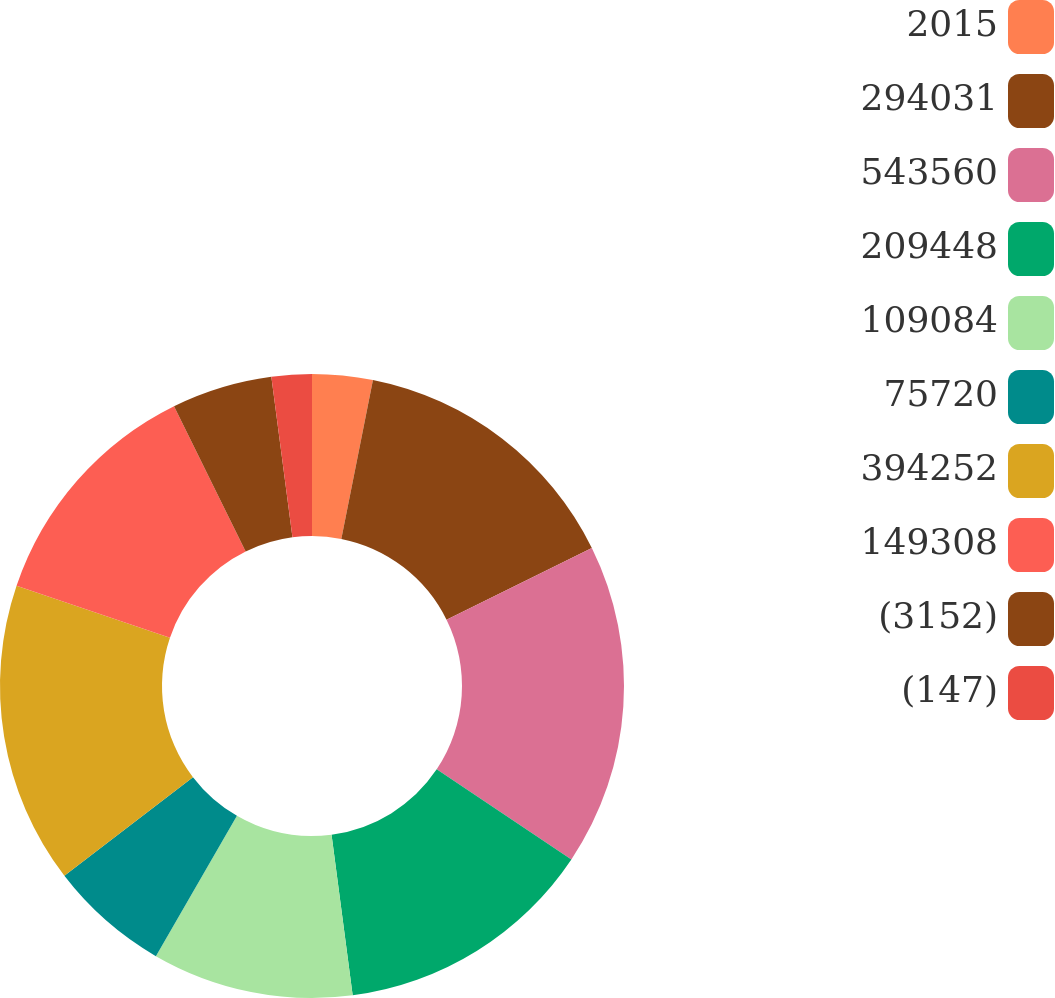Convert chart. <chart><loc_0><loc_0><loc_500><loc_500><pie_chart><fcel>2015<fcel>294031<fcel>543560<fcel>209448<fcel>109084<fcel>75720<fcel>394252<fcel>149308<fcel>(3152)<fcel>(147)<nl><fcel>3.13%<fcel>14.58%<fcel>16.67%<fcel>13.54%<fcel>10.42%<fcel>6.25%<fcel>15.62%<fcel>12.5%<fcel>5.21%<fcel>2.08%<nl></chart> 